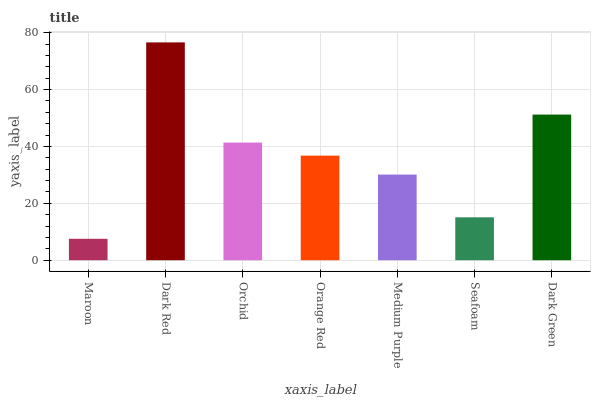Is Maroon the minimum?
Answer yes or no. Yes. Is Dark Red the maximum?
Answer yes or no. Yes. Is Orchid the minimum?
Answer yes or no. No. Is Orchid the maximum?
Answer yes or no. No. Is Dark Red greater than Orchid?
Answer yes or no. Yes. Is Orchid less than Dark Red?
Answer yes or no. Yes. Is Orchid greater than Dark Red?
Answer yes or no. No. Is Dark Red less than Orchid?
Answer yes or no. No. Is Orange Red the high median?
Answer yes or no. Yes. Is Orange Red the low median?
Answer yes or no. Yes. Is Seafoam the high median?
Answer yes or no. No. Is Orchid the low median?
Answer yes or no. No. 